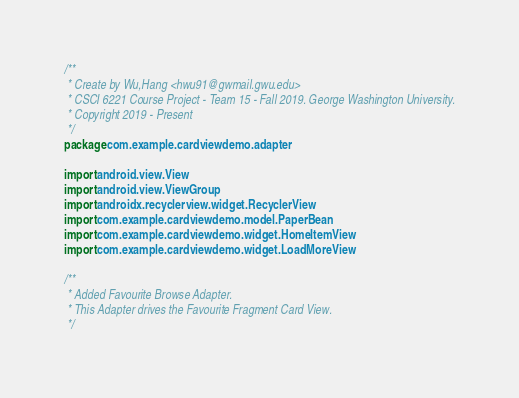Convert code to text. <code><loc_0><loc_0><loc_500><loc_500><_Kotlin_>/**
 * Create by Wu,Hang <hwu91@gwmail.gwu.edu>
 * CSCI 6221 Course Project - Team 15 - Fall 2019. George Washington University.
 * Copyright 2019 - Present
 */
package com.example.cardviewdemo.adapter

import android.view.View
import android.view.ViewGroup
import androidx.recyclerview.widget.RecyclerView
import com.example.cardviewdemo.model.PaperBean
import com.example.cardviewdemo.widget.HomeItemView
import com.example.cardviewdemo.widget.LoadMoreView

/**
 * Added Favourite Browse Adapter.
 * This Adapter drives the Favourite Fragment Card View.
 */</code> 